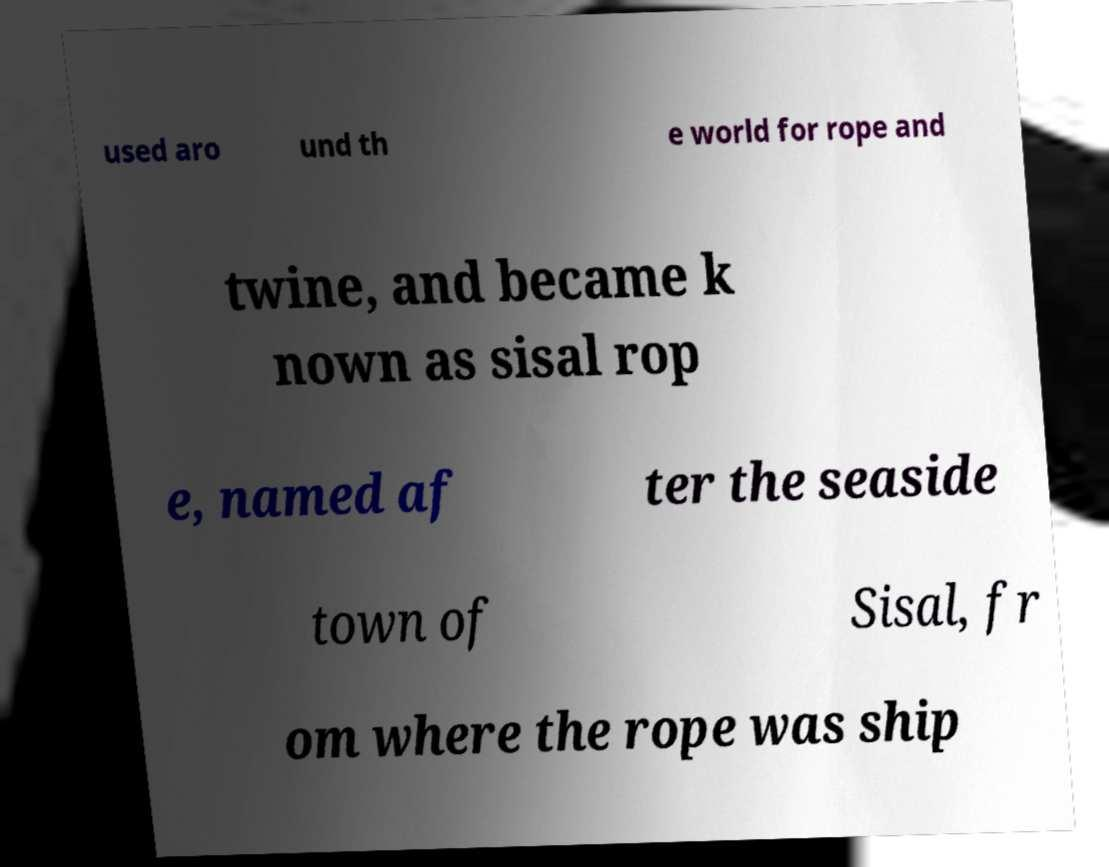What messages or text are displayed in this image? I need them in a readable, typed format. used aro und th e world for rope and twine, and became k nown as sisal rop e, named af ter the seaside town of Sisal, fr om where the rope was ship 